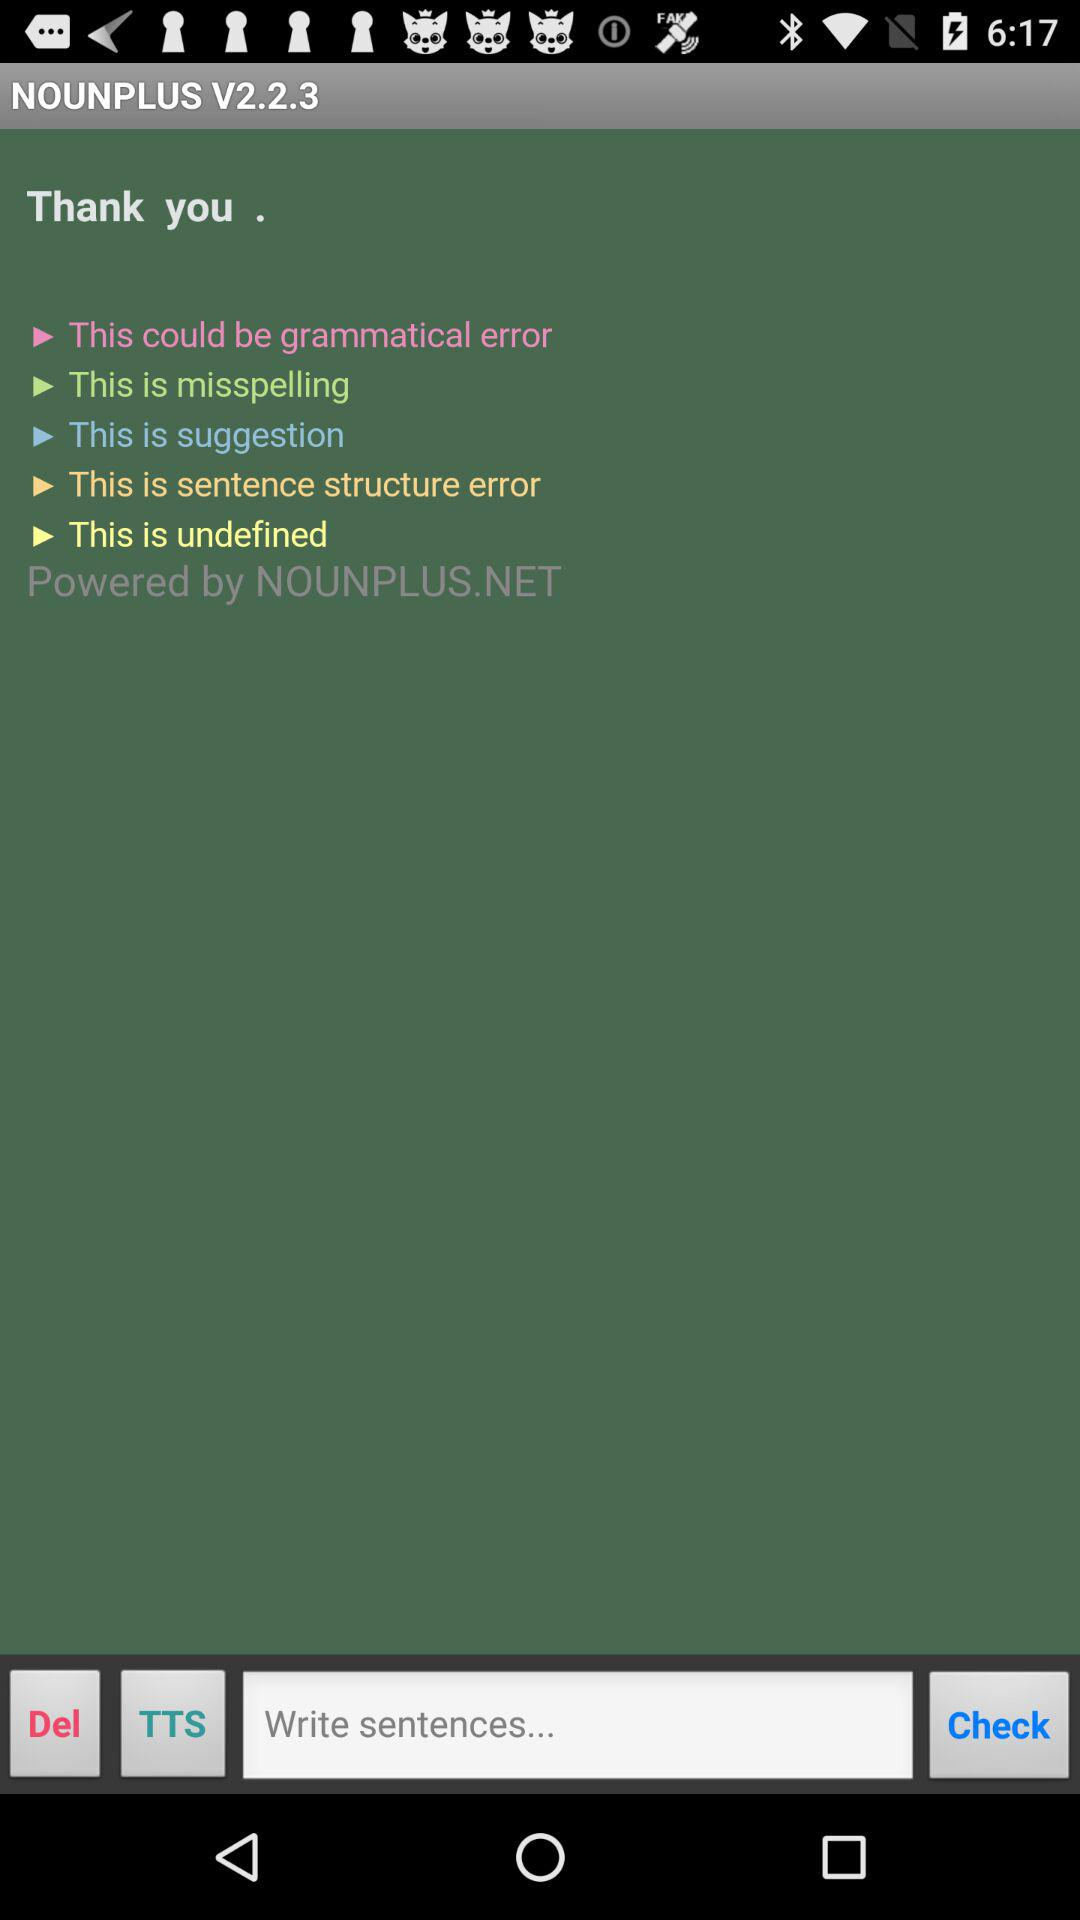What does TTS stand for?
When the provided information is insufficient, respond with <no answer>. <no answer> 